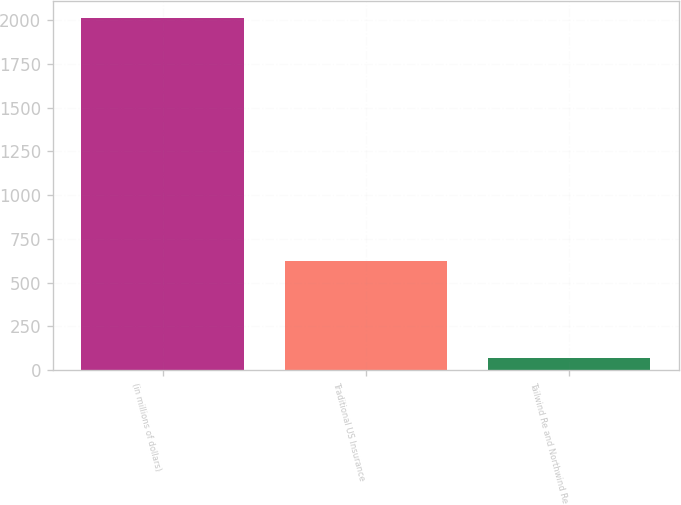<chart> <loc_0><loc_0><loc_500><loc_500><bar_chart><fcel>(in millions of dollars)<fcel>Traditional US Insurance<fcel>Tailwind Re and Northwind Re<nl><fcel>2012<fcel>624.5<fcel>69.7<nl></chart> 